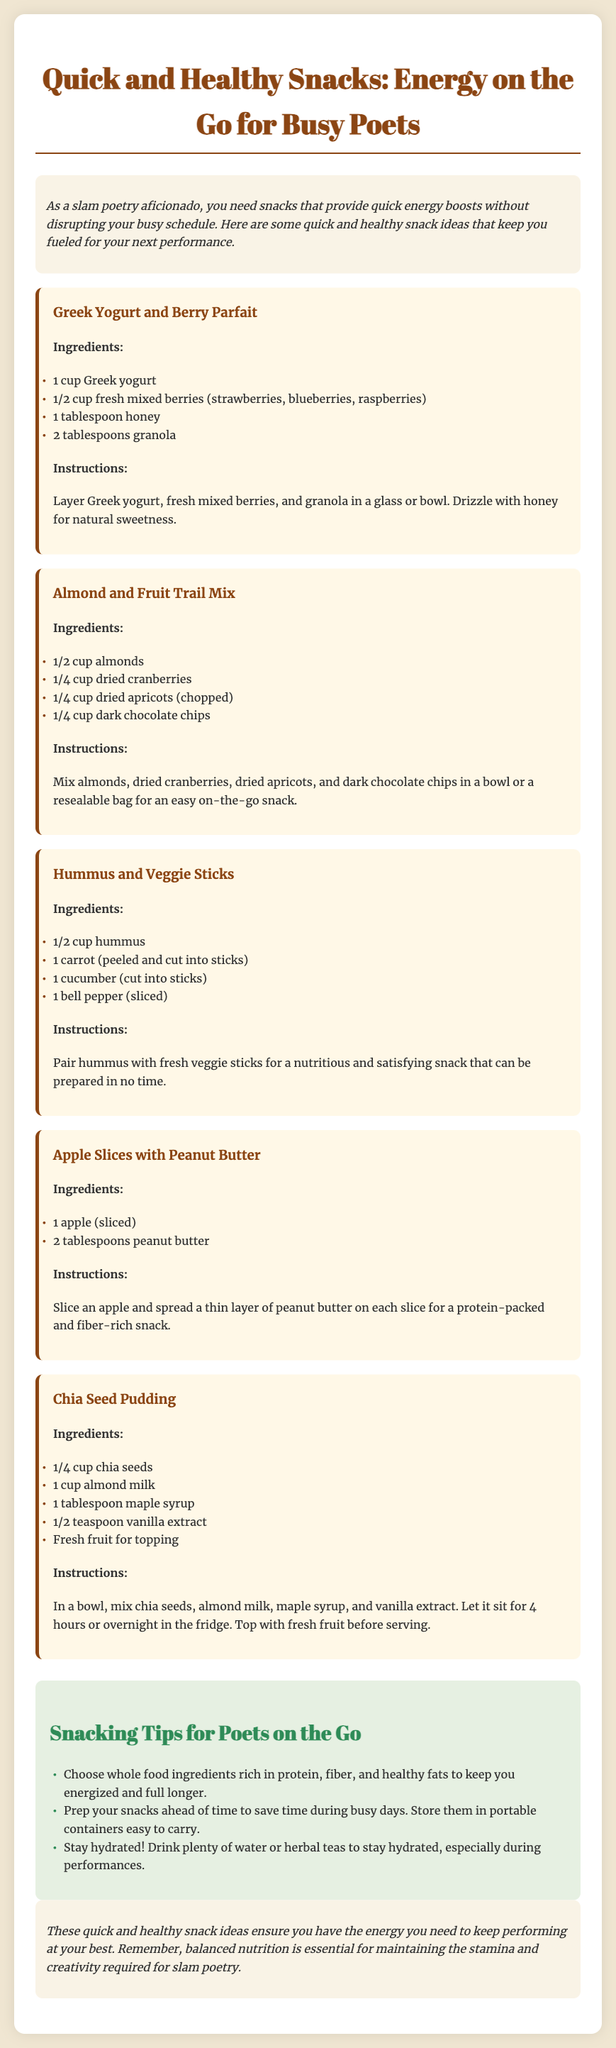What is the title of the document? The title is located at the top of the document, showing what the document is about.
Answer: Quick and Healthy Snacks: Energy on the Go for Busy Poets How many snacks are listed in the meal plan? By counting the individual meal sections in the document, we determine the total number of snacks provided.
Answer: Five What is the first ingredient in the Greek Yogurt and Berry Parfait? The ingredients list for this snack is provided, specifying the first item mentioned.
Answer: 1 cup Greek yogurt What type of milk is used in the Chia Seed Pudding? The ingredients section clearly states what type of milk is included in this recipe.
Answer: almond milk What snack includes fruit and nuts? The snack options are reviewed to see which ones specifically contain both fruits and nuts.
Answer: Almond and Fruit Trail Mix Which snack requires the use of a blender? The instructions are examined to identify if any snacks specifically mention using a blender.
Answer: None What is a tip for busy poets regarding snack preparation? The tips section shares advice for poets on managing their snacking efficiently.
Answer: Prep your snacks ahead of time Which ingredient is used for sweetness in the Chia Seed Pudding? The ingredients list for this pudding indicates what is used to provide sweetness.
Answer: maple syrup What should poets stay hydrated with during performances? The tips section provides recommendations for hydration during performances for poets.
Answer: water or herbal teas 